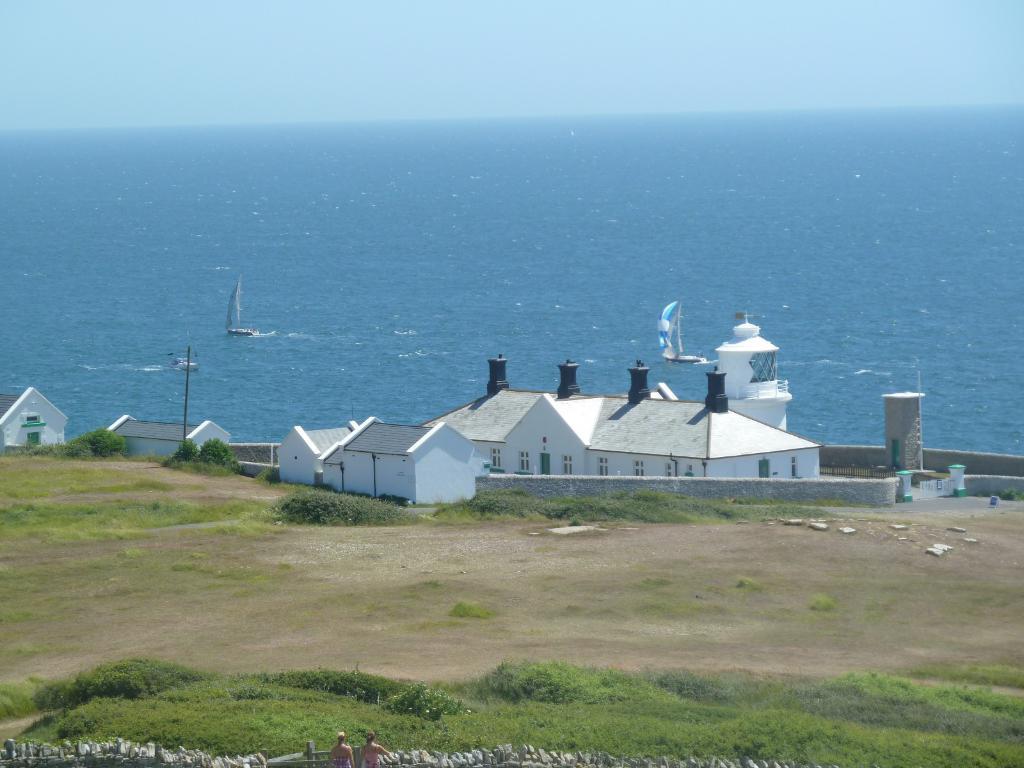In one or two sentences, can you explain what this image depicts? In this image we can see some houses and there are some plants and grass on the ground. We can see two people are standing at the bottom of the image and we can see the water and there are few boats. 